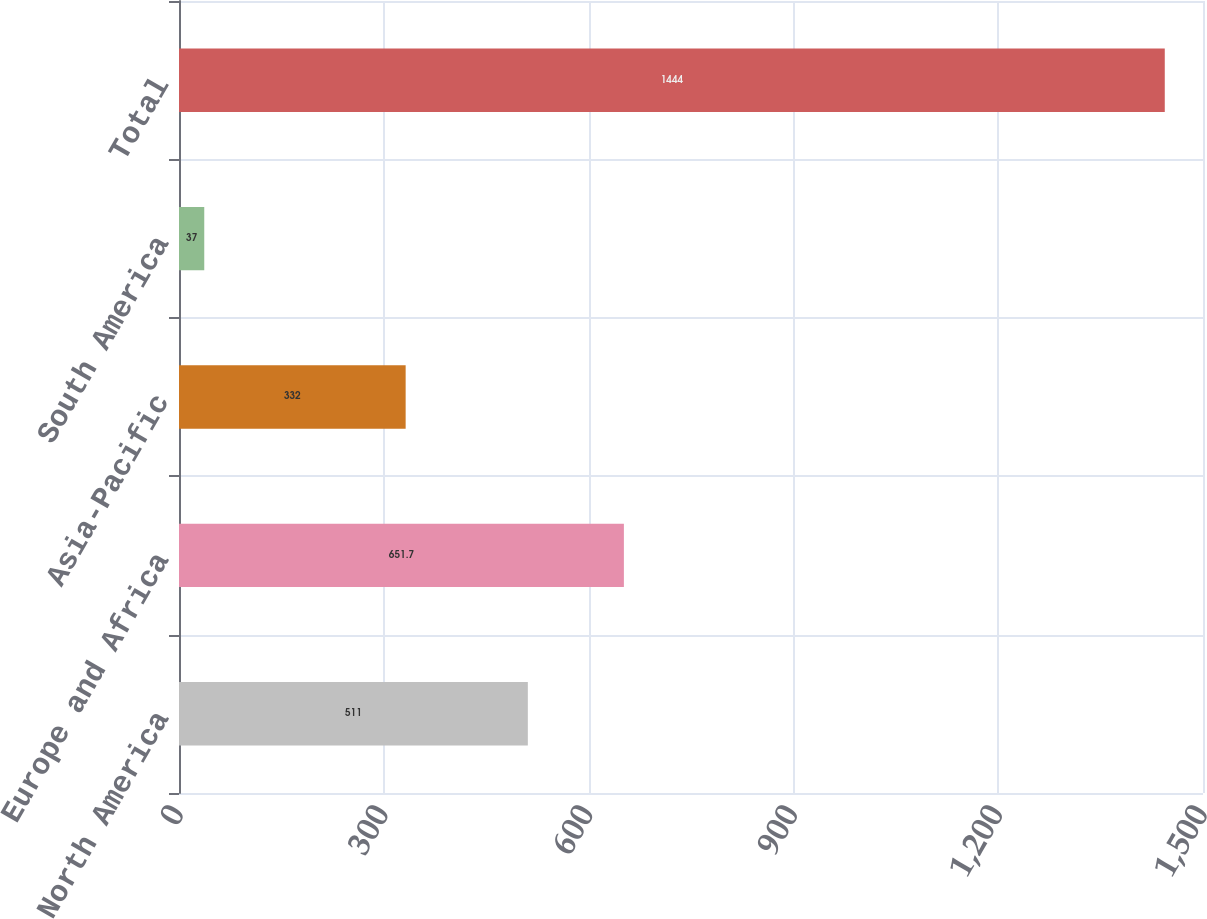Convert chart. <chart><loc_0><loc_0><loc_500><loc_500><bar_chart><fcel>North America<fcel>Europe and Africa<fcel>Asia-Pacific<fcel>South America<fcel>Total<nl><fcel>511<fcel>651.7<fcel>332<fcel>37<fcel>1444<nl></chart> 